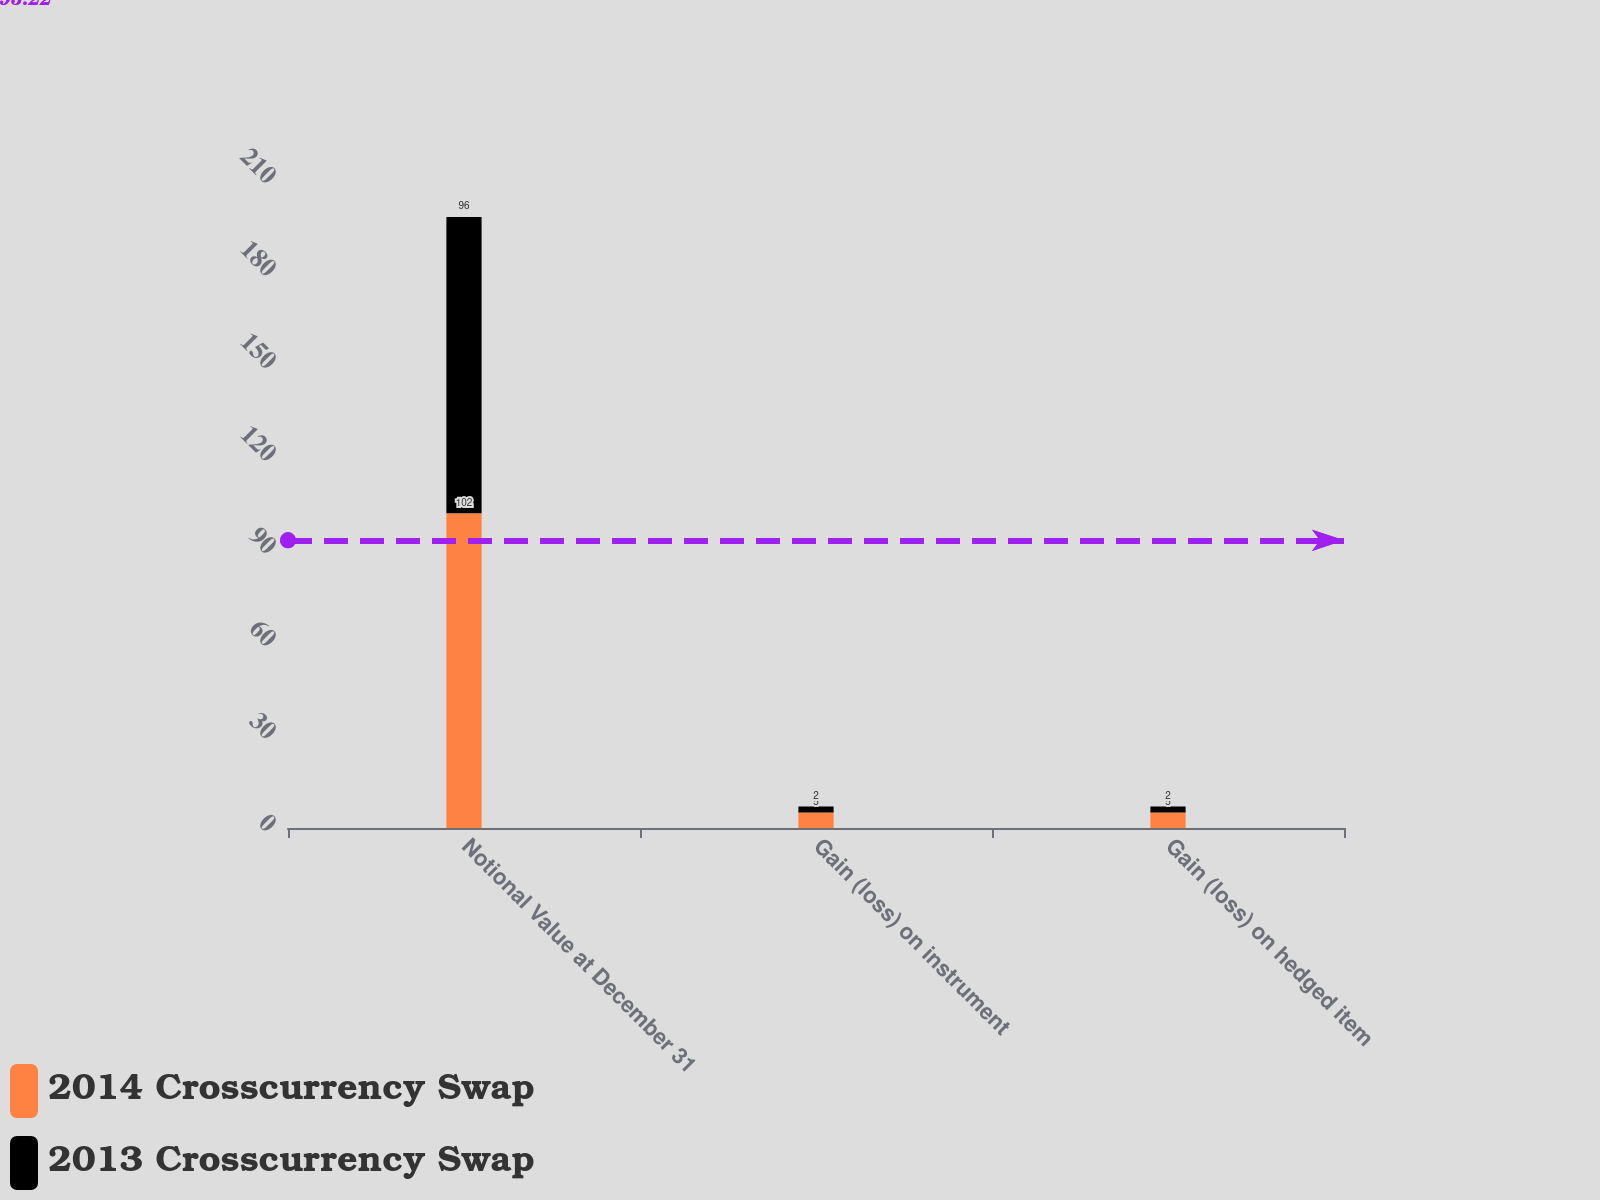Convert chart to OTSL. <chart><loc_0><loc_0><loc_500><loc_500><stacked_bar_chart><ecel><fcel>Notional Value at December 31<fcel>Gain (loss) on instrument<fcel>Gain (loss) on hedged item<nl><fcel>2014 Crosscurrency Swap<fcel>102<fcel>5<fcel>5<nl><fcel>2013 Crosscurrency Swap<fcel>96<fcel>2<fcel>2<nl></chart> 